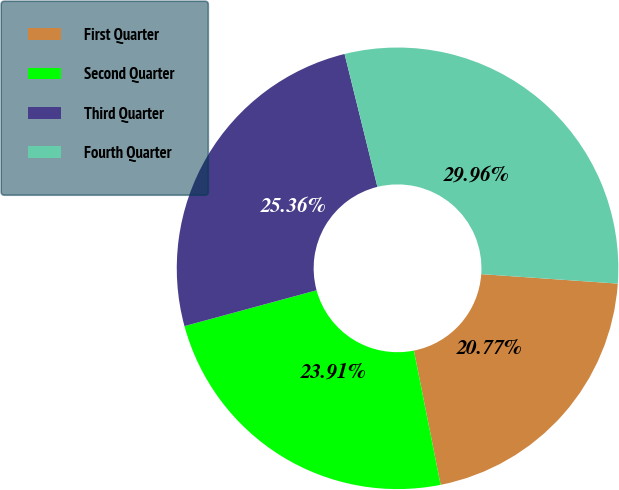<chart> <loc_0><loc_0><loc_500><loc_500><pie_chart><fcel>First Quarter<fcel>Second Quarter<fcel>Third Quarter<fcel>Fourth Quarter<nl><fcel>20.77%<fcel>23.91%<fcel>25.36%<fcel>29.96%<nl></chart> 